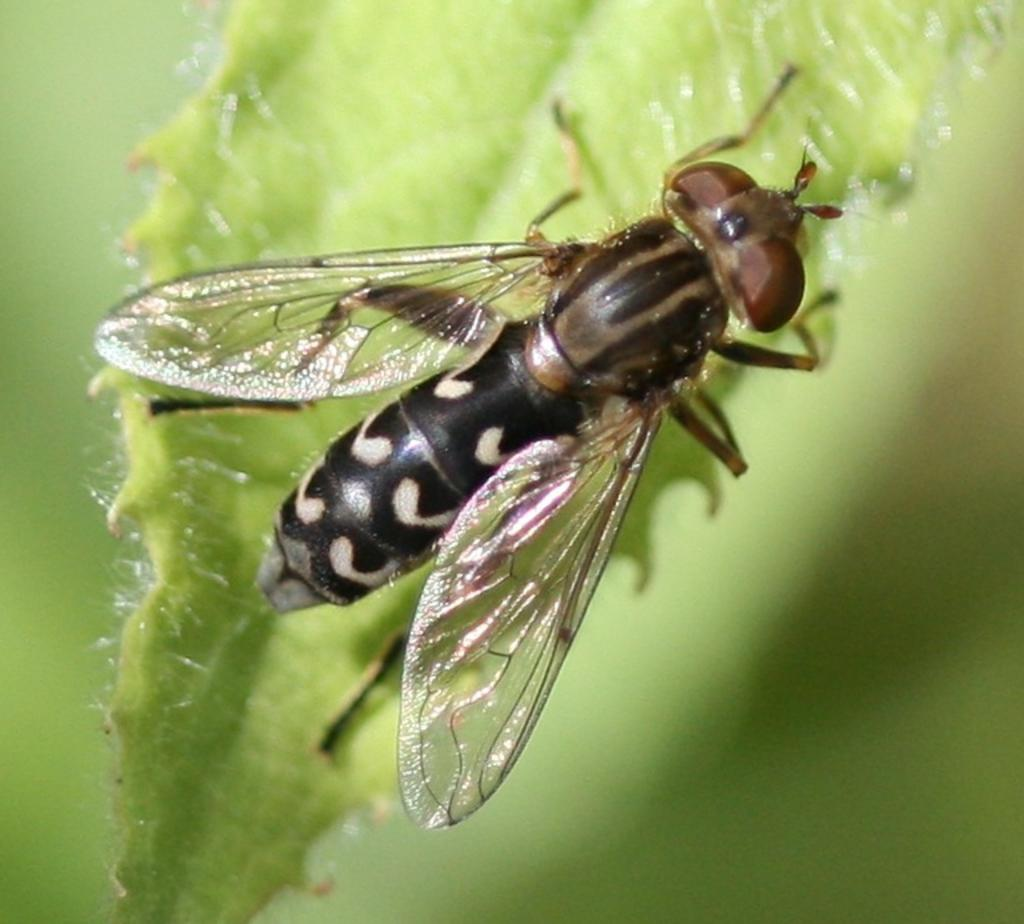What type of insect is in the picture? There is a net-winged insect in the picture. Where is the insect located? The insect is on a green leaf. What type of train can be seen passing by in the image? There is no train present in the image; it features a net-winged insect on a green leaf. How does the insect contribute to the expansion of the leaf? The insect does not contribute to the expansion of the leaf; it is simply resting on it. 